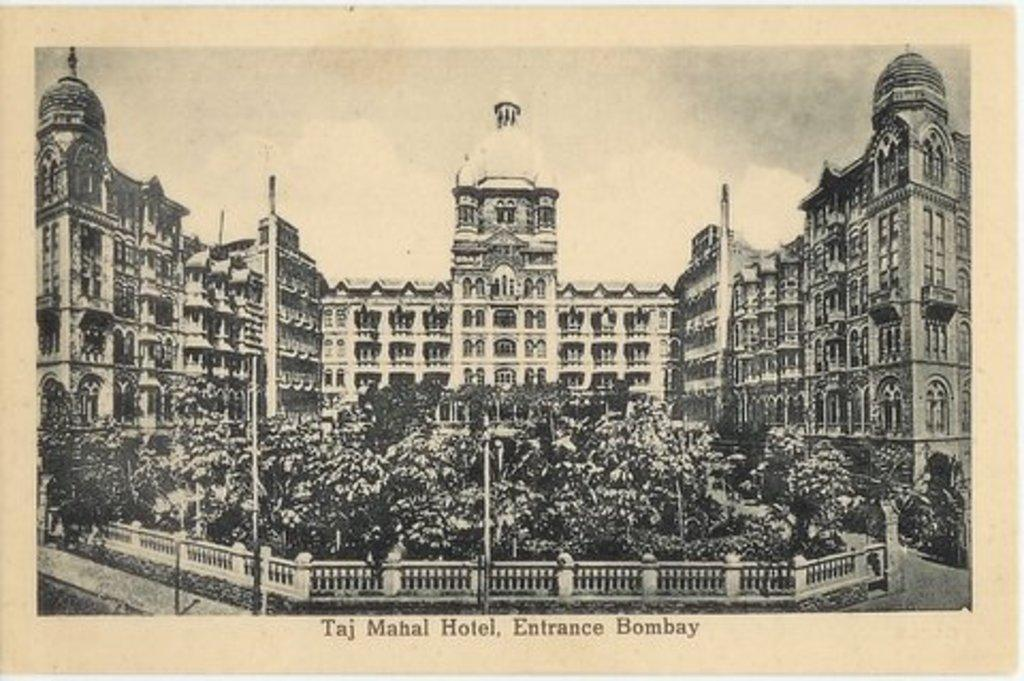<image>
Offer a succinct explanation of the picture presented. An old black and white photo of the Taj Mahal Hotel Entrance 